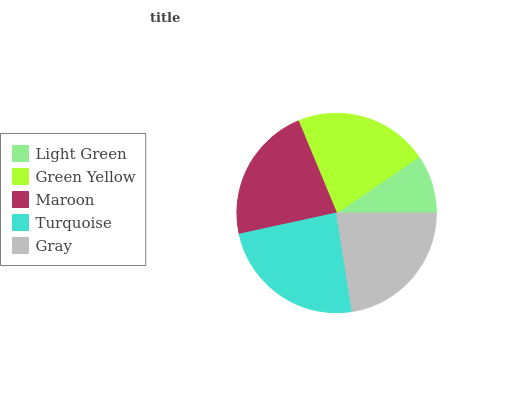Is Light Green the minimum?
Answer yes or no. Yes. Is Turquoise the maximum?
Answer yes or no. Yes. Is Green Yellow the minimum?
Answer yes or no. No. Is Green Yellow the maximum?
Answer yes or no. No. Is Green Yellow greater than Light Green?
Answer yes or no. Yes. Is Light Green less than Green Yellow?
Answer yes or no. Yes. Is Light Green greater than Green Yellow?
Answer yes or no. No. Is Green Yellow less than Light Green?
Answer yes or no. No. Is Maroon the high median?
Answer yes or no. Yes. Is Maroon the low median?
Answer yes or no. Yes. Is Turquoise the high median?
Answer yes or no. No. Is Light Green the low median?
Answer yes or no. No. 